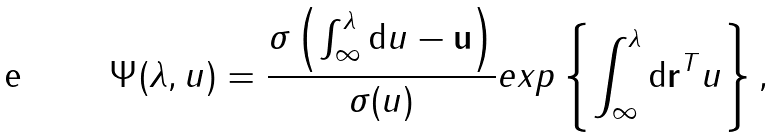<formula> <loc_0><loc_0><loc_500><loc_500>\Psi ( \lambda , u ) = \frac { \sigma \left ( \int _ { \infty } ^ { \lambda } { \mathrm d } u - { \mathbf u } \right ) } { \sigma ( u ) } e x p \left \{ \int _ { \infty } ^ { \lambda } { \mathrm d } { \mathbf r } ^ { T } u \right \} ,</formula> 